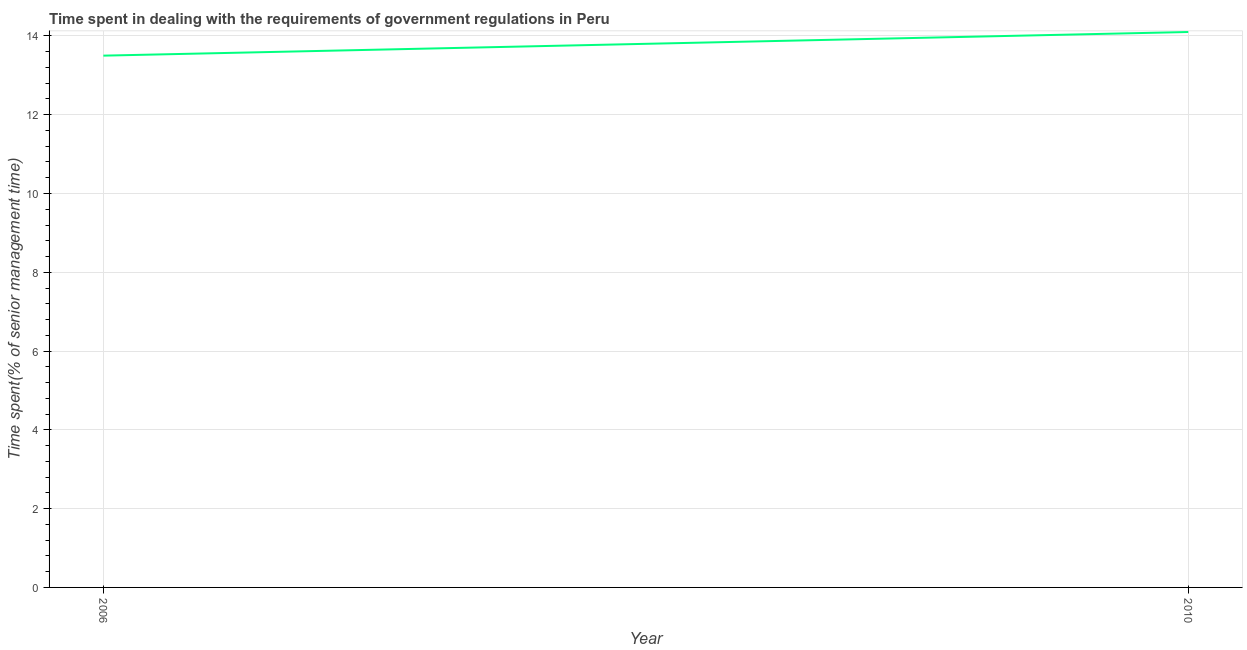What is the time spent in dealing with government regulations in 2010?
Keep it short and to the point. 14.1. Across all years, what is the maximum time spent in dealing with government regulations?
Provide a succinct answer. 14.1. Across all years, what is the minimum time spent in dealing with government regulations?
Keep it short and to the point. 13.5. In which year was the time spent in dealing with government regulations maximum?
Make the answer very short. 2010. In which year was the time spent in dealing with government regulations minimum?
Make the answer very short. 2006. What is the sum of the time spent in dealing with government regulations?
Ensure brevity in your answer.  27.6. What is the difference between the time spent in dealing with government regulations in 2006 and 2010?
Keep it short and to the point. -0.6. What is the median time spent in dealing with government regulations?
Offer a terse response. 13.8. What is the ratio of the time spent in dealing with government regulations in 2006 to that in 2010?
Make the answer very short. 0.96. Is the time spent in dealing with government regulations in 2006 less than that in 2010?
Keep it short and to the point. Yes. How many lines are there?
Give a very brief answer. 1. Does the graph contain grids?
Offer a very short reply. Yes. What is the title of the graph?
Ensure brevity in your answer.  Time spent in dealing with the requirements of government regulations in Peru. What is the label or title of the X-axis?
Your answer should be compact. Year. What is the label or title of the Y-axis?
Offer a very short reply. Time spent(% of senior management time). What is the Time spent(% of senior management time) of 2006?
Make the answer very short. 13.5. What is the ratio of the Time spent(% of senior management time) in 2006 to that in 2010?
Your answer should be compact. 0.96. 